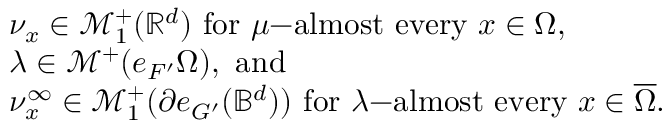<formula> <loc_0><loc_0><loc_500><loc_500>\begin{array} { r l } & { \nu _ { x } \in \mathcal { M } _ { 1 } ^ { + } ( \mathbb { R } ^ { d } ) f o r \mu - a l m o s t e v e r y x \in \Omega , } \\ & { \lambda \in \mathcal { M } ^ { + } ( e _ { F ^ { \prime } } \Omega ) , a n d } \\ & { \nu _ { x } ^ { \infty } \in \mathcal { M } _ { 1 } ^ { + } ( \partial e _ { G ^ { \prime } } ( \mathbb { B } ^ { d } ) ) f o r \lambda - a l m o s t e v e r y x \in \overline { \Omega } . } \end{array}</formula> 